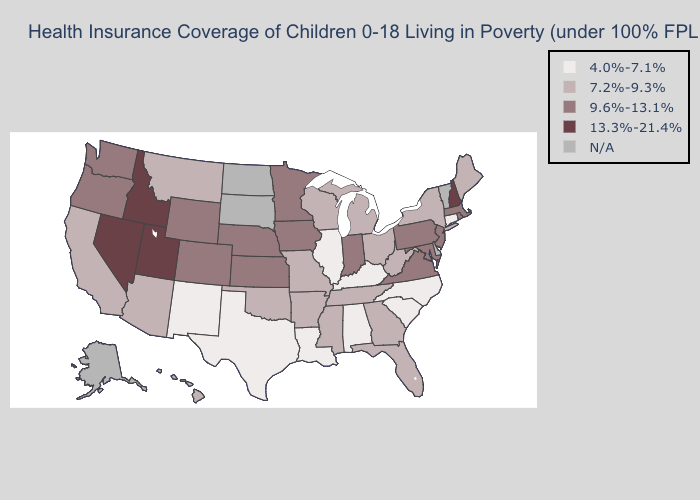Name the states that have a value in the range 13.3%-21.4%?
Short answer required. Idaho, Nevada, New Hampshire, Utah. Which states have the highest value in the USA?
Answer briefly. Idaho, Nevada, New Hampshire, Utah. Does Wyoming have the lowest value in the West?
Keep it brief. No. Name the states that have a value in the range N/A?
Concise answer only. Alaska, Delaware, North Dakota, South Dakota, Vermont. Is the legend a continuous bar?
Give a very brief answer. No. What is the highest value in the USA?
Keep it brief. 13.3%-21.4%. Name the states that have a value in the range 4.0%-7.1%?
Give a very brief answer. Alabama, Connecticut, Illinois, Kentucky, Louisiana, New Mexico, North Carolina, South Carolina, Texas. Does Idaho have the highest value in the USA?
Quick response, please. Yes. Does the map have missing data?
Concise answer only. Yes. Which states hav the highest value in the South?
Quick response, please. Maryland, Virginia. Which states have the lowest value in the USA?
Be succinct. Alabama, Connecticut, Illinois, Kentucky, Louisiana, New Mexico, North Carolina, South Carolina, Texas. Name the states that have a value in the range 9.6%-13.1%?
Concise answer only. Colorado, Indiana, Iowa, Kansas, Maryland, Massachusetts, Minnesota, Nebraska, New Jersey, Oregon, Pennsylvania, Rhode Island, Virginia, Washington, Wyoming. Name the states that have a value in the range 4.0%-7.1%?
Concise answer only. Alabama, Connecticut, Illinois, Kentucky, Louisiana, New Mexico, North Carolina, South Carolina, Texas. What is the value of Louisiana?
Give a very brief answer. 4.0%-7.1%. Which states have the lowest value in the MidWest?
Be succinct. Illinois. 